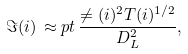<formula> <loc_0><loc_0><loc_500><loc_500>\Im ( i ) \, \approx p t \, \frac { \ne ( i ) ^ { 2 } T ( i ) ^ { 1 / 2 } } { D _ { L } ^ { 2 } } ,</formula> 